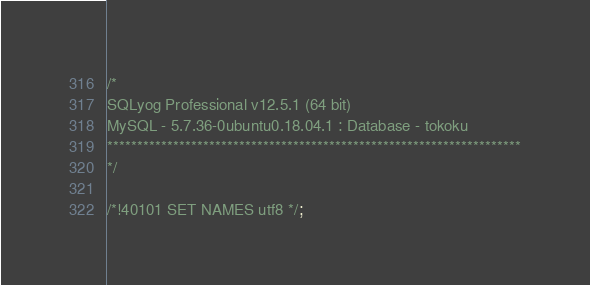<code> <loc_0><loc_0><loc_500><loc_500><_SQL_>/*
SQLyog Professional v12.5.1 (64 bit)
MySQL - 5.7.36-0ubuntu0.18.04.1 : Database - tokoku
*********************************************************************
*/

/*!40101 SET NAMES utf8 */;
</code> 